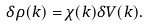Convert formula to latex. <formula><loc_0><loc_0><loc_500><loc_500>\delta \rho ( { k } ) = \chi ( { k } ) \delta V ( { k } ) .</formula> 